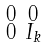Convert formula to latex. <formula><loc_0><loc_0><loc_500><loc_500>\begin{smallmatrix} 0 & 0 \\ 0 & I _ { k } \end{smallmatrix}</formula> 